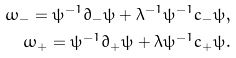<formula> <loc_0><loc_0><loc_500><loc_500>\omega _ { - } = \psi ^ { - 1 } \partial _ { - } \psi + \lambda ^ { - 1 } \psi ^ { - 1 } c _ { - } \psi , \\ \omega _ { + } = \psi ^ { - 1 } \partial _ { + } \psi + \lambda \psi ^ { - 1 } c _ { + } \psi .</formula> 